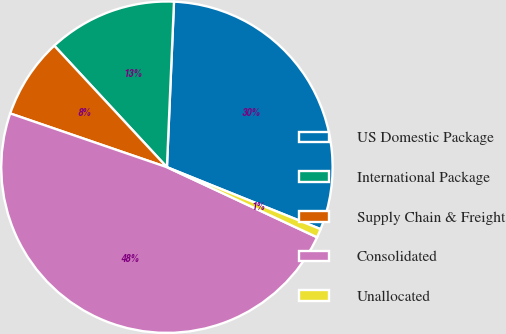<chart> <loc_0><loc_0><loc_500><loc_500><pie_chart><fcel>US Domestic Package<fcel>International Package<fcel>Supply Chain & Freight<fcel>Consolidated<fcel>Unallocated<nl><fcel>30.42%<fcel>12.58%<fcel>7.84%<fcel>48.31%<fcel>0.85%<nl></chart> 